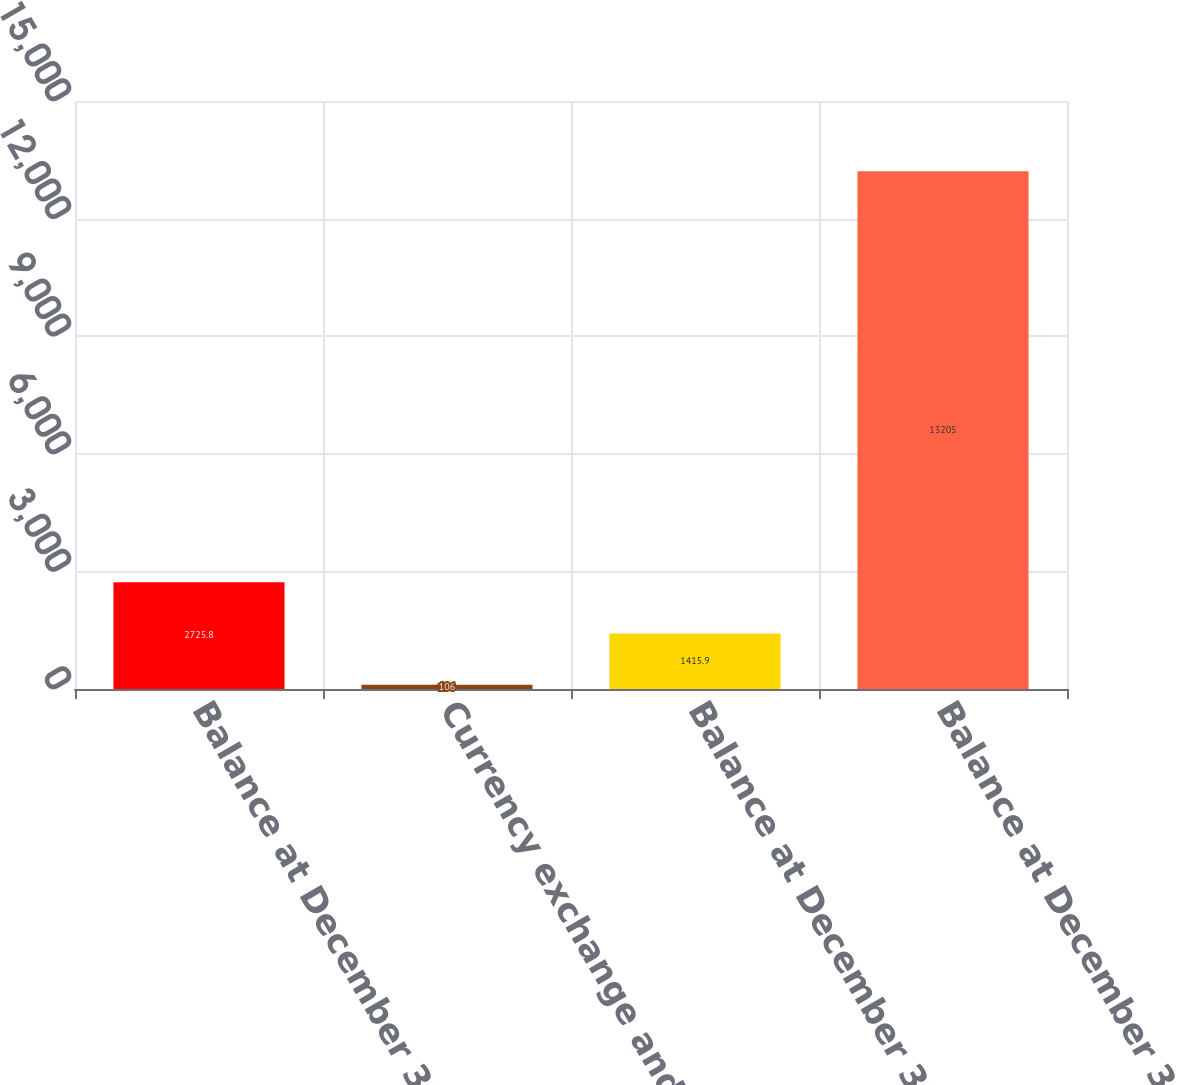Convert chart. <chart><loc_0><loc_0><loc_500><loc_500><bar_chart><fcel>Balance at December 31 2015<fcel>Currency exchange and others<fcel>Balance at December 31 2016<fcel>Balance at December 31 2017<nl><fcel>2725.8<fcel>106<fcel>1415.9<fcel>13205<nl></chart> 